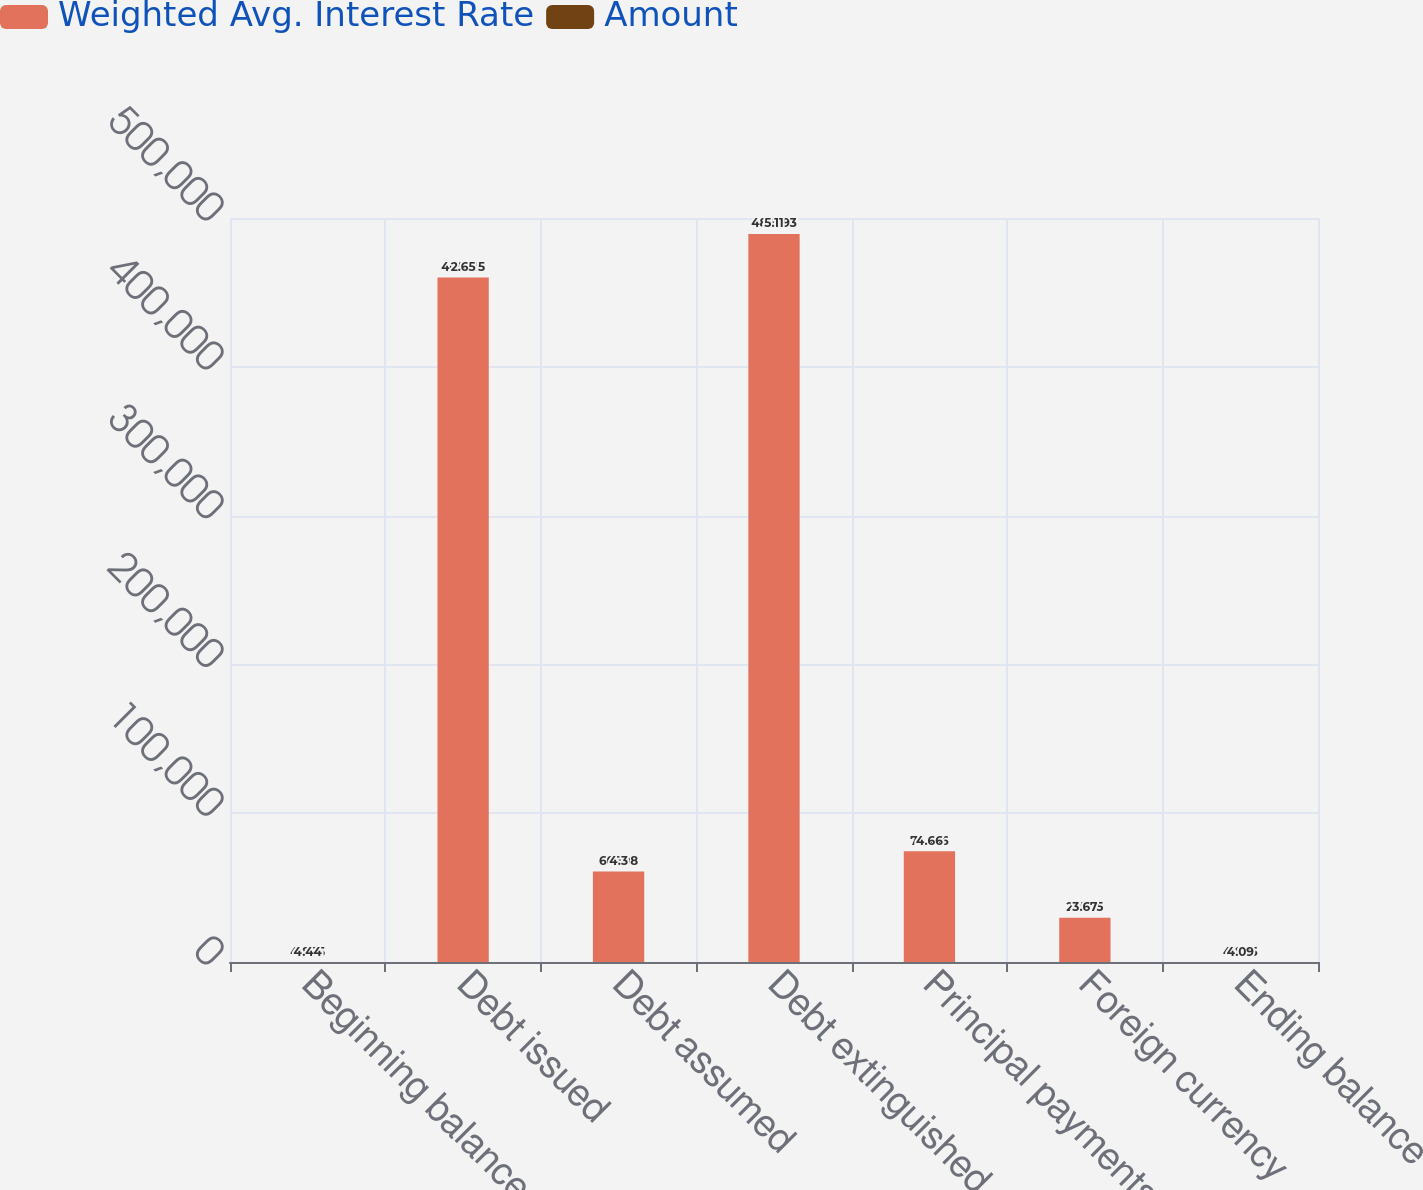Convert chart. <chart><loc_0><loc_0><loc_500><loc_500><stacked_bar_chart><ecel><fcel>Beginning balance<fcel>Debt issued<fcel>Debt assumed<fcel>Debt extinguished<fcel>Principal payments<fcel>Foreign currency<fcel>Ending balance<nl><fcel>Weighted Avg. Interest Rate<fcel>4.885<fcel>460015<fcel>60898<fcel>489293<fcel>74466<fcel>29705<fcel>4.885<nl><fcel>Amount<fcel>4.44<fcel>2.65<fcel>4.3<fcel>5.11<fcel>4.66<fcel>3.67<fcel>4.09<nl></chart> 